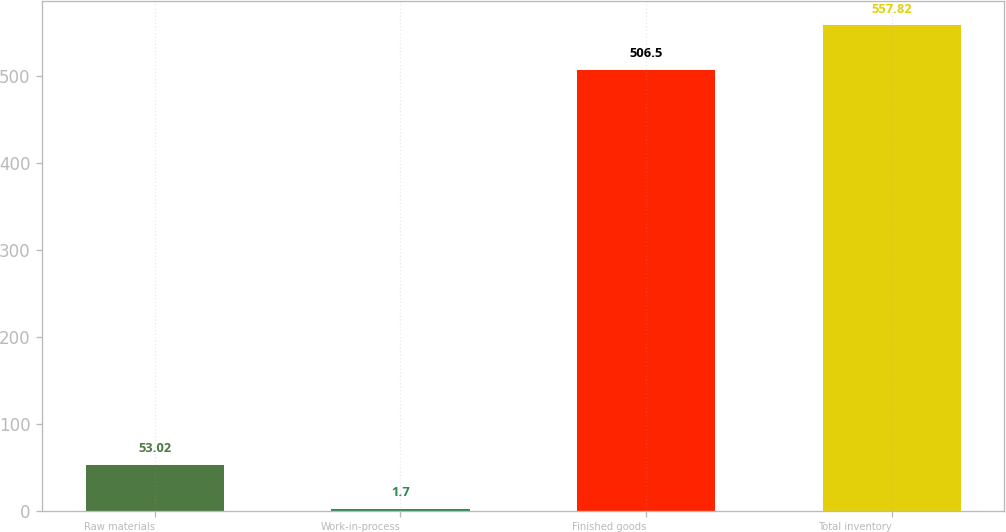<chart> <loc_0><loc_0><loc_500><loc_500><bar_chart><fcel>Raw materials<fcel>Work-in-process<fcel>Finished goods<fcel>Total inventory<nl><fcel>53.02<fcel>1.7<fcel>506.5<fcel>557.82<nl></chart> 